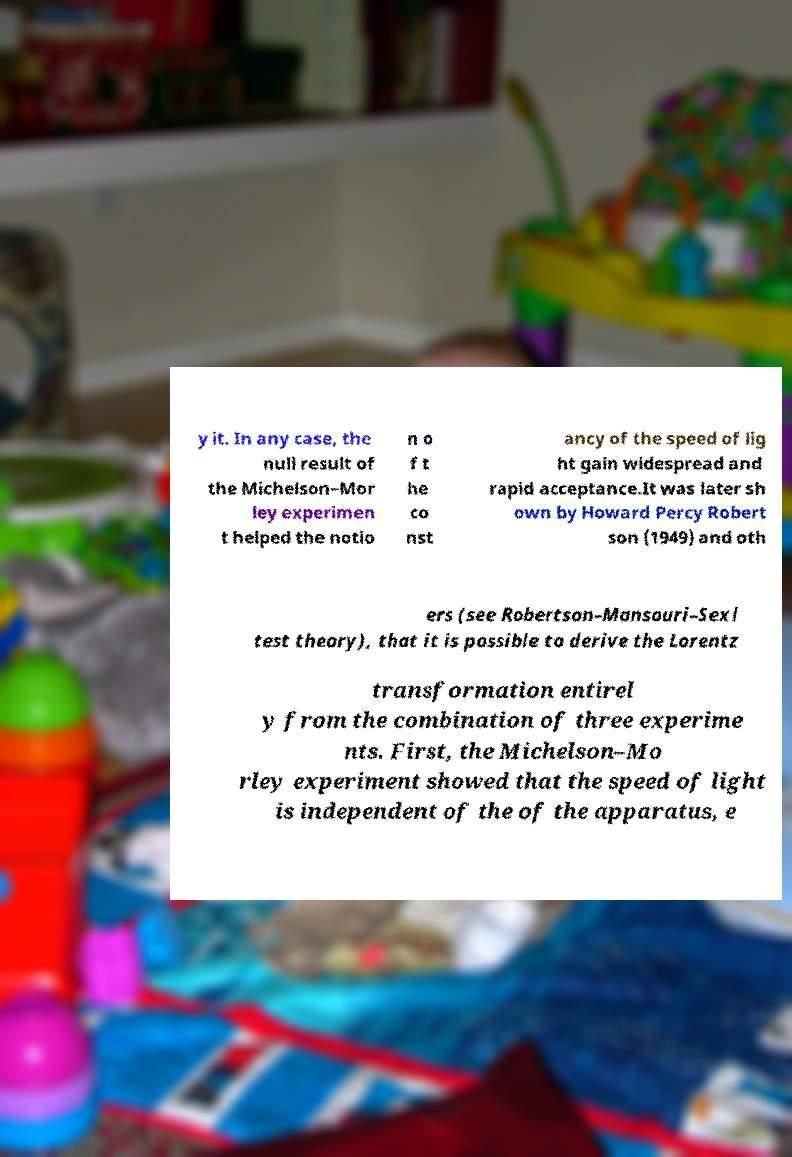For documentation purposes, I need the text within this image transcribed. Could you provide that? y it. In any case, the null result of the Michelson–Mor ley experimen t helped the notio n o f t he co nst ancy of the speed of lig ht gain widespread and rapid acceptance.It was later sh own by Howard Percy Robert son (1949) and oth ers (see Robertson–Mansouri–Sexl test theory), that it is possible to derive the Lorentz transformation entirel y from the combination of three experime nts. First, the Michelson–Mo rley experiment showed that the speed of light is independent of the of the apparatus, e 